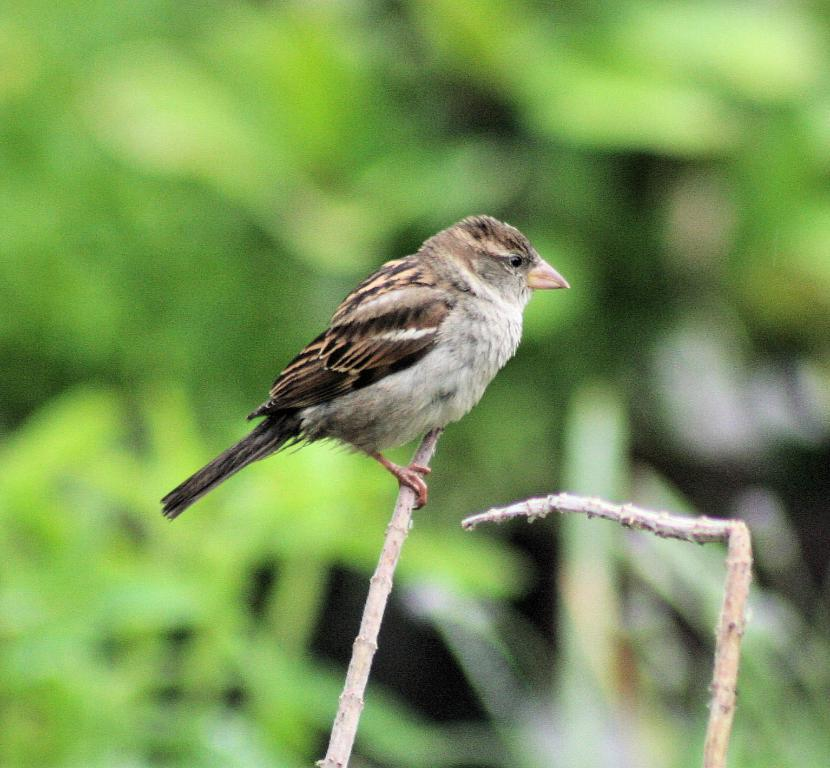What type of animal can be seen in the image? There is a bird in the image. Where is the bird located? The bird is on a branch. Can you describe the background of the image? The background of the image is blurred. How many icicles are hanging from the bird's beak in the image? There are no icicles present in the image. What type of bikes can be seen in the background of the image? There are no bikes visible in the image, as the background is blurred. 